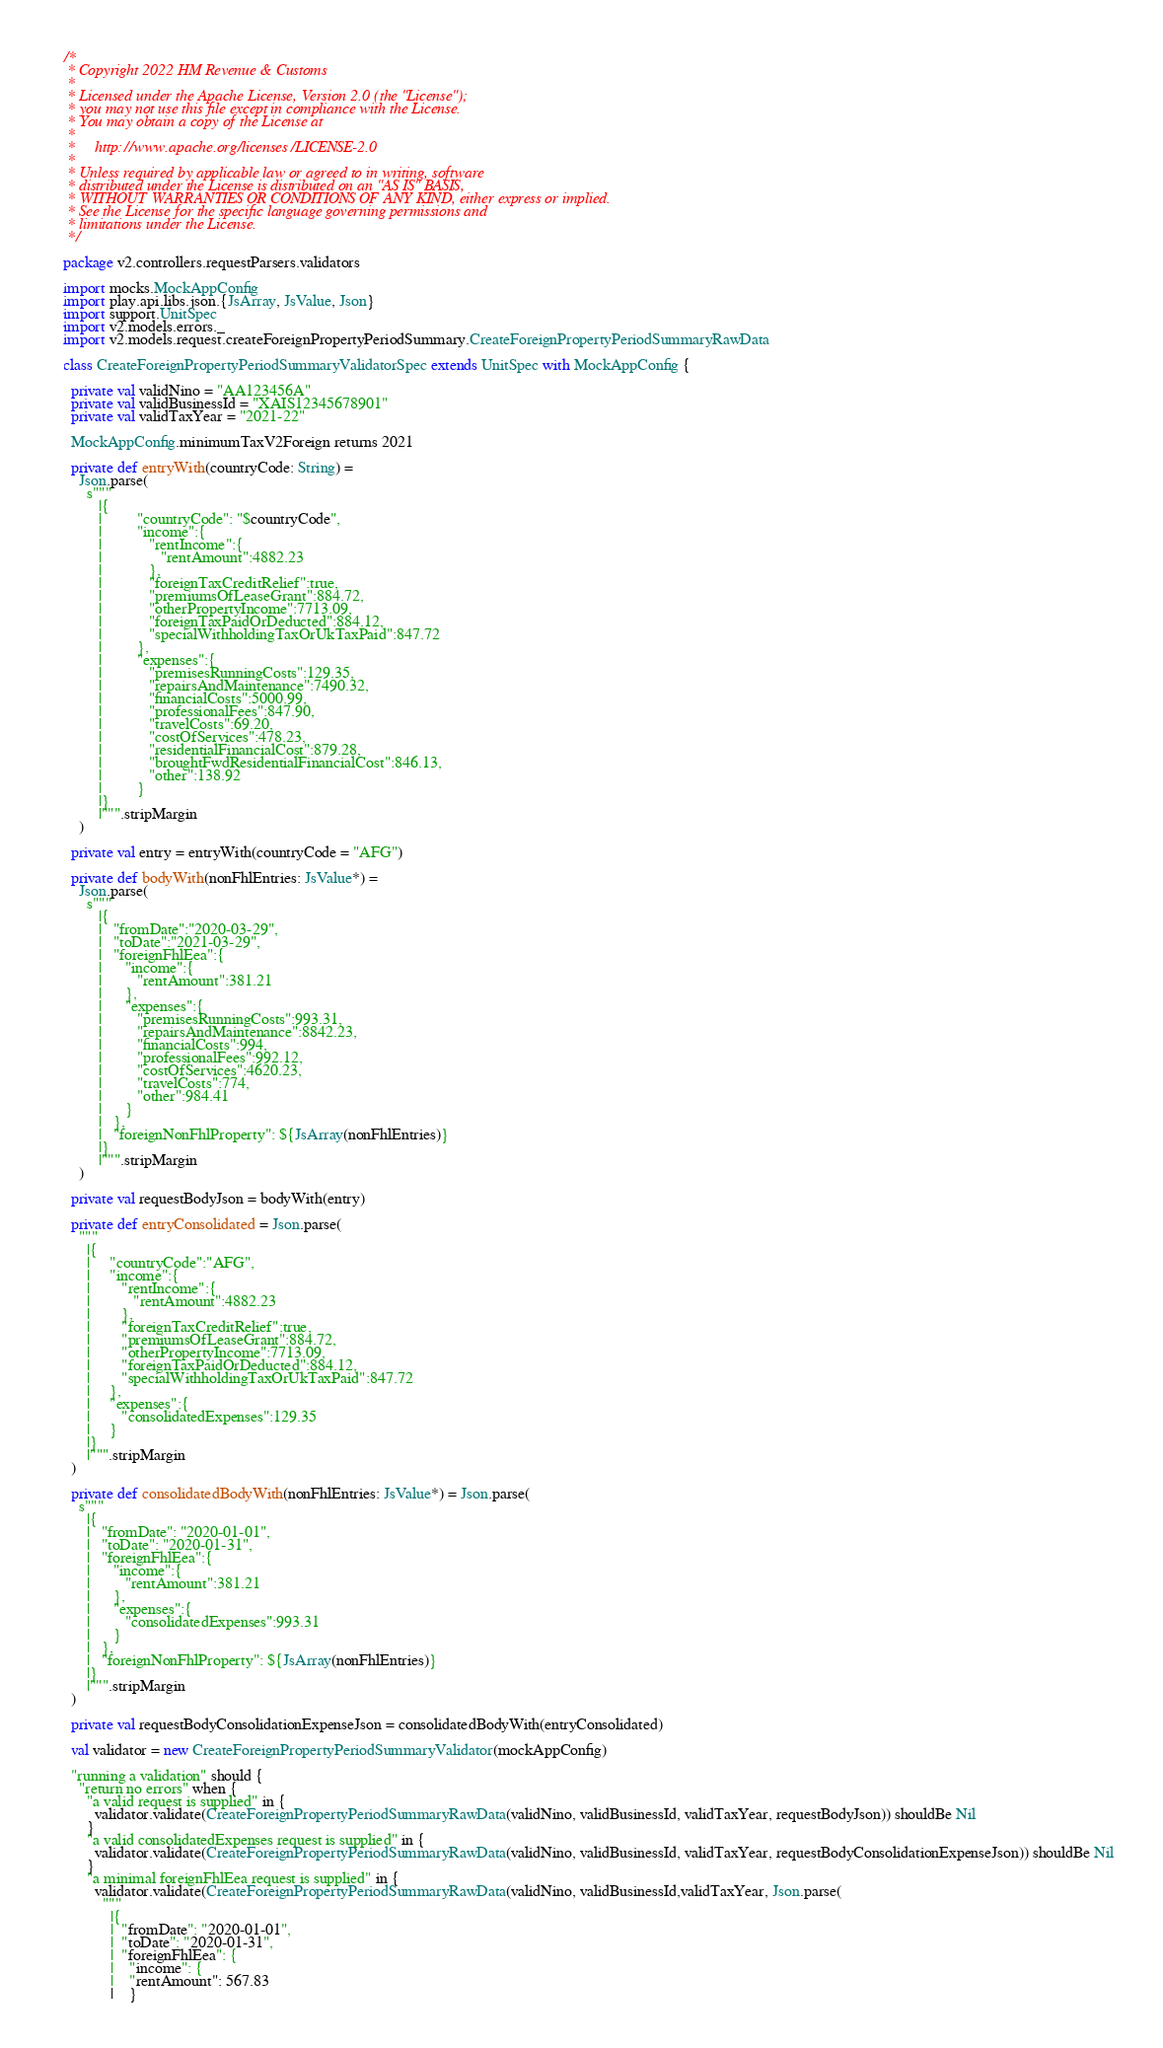<code> <loc_0><loc_0><loc_500><loc_500><_Scala_>/*
 * Copyright 2022 HM Revenue & Customs
 *
 * Licensed under the Apache License, Version 2.0 (the "License");
 * you may not use this file except in compliance with the License.
 * You may obtain a copy of the License at
 *
 *     http://www.apache.org/licenses/LICENSE-2.0
 *
 * Unless required by applicable law or agreed to in writing, software
 * distributed under the License is distributed on an "AS IS" BASIS,
 * WITHOUT WARRANTIES OR CONDITIONS OF ANY KIND, either express or implied.
 * See the License for the specific language governing permissions and
 * limitations under the License.
 */

package v2.controllers.requestParsers.validators

import mocks.MockAppConfig
import play.api.libs.json.{JsArray, JsValue, Json}
import support.UnitSpec
import v2.models.errors._
import v2.models.request.createForeignPropertyPeriodSummary.CreateForeignPropertyPeriodSummaryRawData

class CreateForeignPropertyPeriodSummaryValidatorSpec extends UnitSpec with MockAppConfig {

  private val validNino = "AA123456A"
  private val validBusinessId = "XAIS12345678901"
  private val validTaxYear = "2021-22"

  MockAppConfig.minimumTaxV2Foreign returns 2021

  private def entryWith(countryCode: String) =
    Json.parse(
      s"""
         |{
         |         "countryCode": "$countryCode",
         |         "income":{
         |            "rentIncome":{
         |               "rentAmount":4882.23
         |            },
         |            "foreignTaxCreditRelief":true,
         |            "premiumsOfLeaseGrant":884.72,
         |            "otherPropertyIncome":7713.09,
         |            "foreignTaxPaidOrDeducted":884.12,
         |            "specialWithholdingTaxOrUkTaxPaid":847.72
         |         },
         |         "expenses":{
         |            "premisesRunningCosts":129.35,
         |            "repairsAndMaintenance":7490.32,
         |            "financialCosts":5000.99,
         |            "professionalFees":847.90,
         |            "travelCosts":69.20,
         |            "costOfServices":478.23,
         |            "residentialFinancialCost":879.28,
         |            "broughtFwdResidentialFinancialCost":846.13,
         |            "other":138.92
         |         }
         |}
         |""".stripMargin
    )

  private val entry = entryWith(countryCode = "AFG")

  private def bodyWith(nonFhlEntries: JsValue*) =
    Json.parse(
      s"""
         |{
         |   "fromDate":"2020-03-29",
         |   "toDate":"2021-03-29",
         |   "foreignFhlEea":{
         |      "income":{
         |         "rentAmount":381.21
         |      },
         |      "expenses":{
         |         "premisesRunningCosts":993.31,
         |         "repairsAndMaintenance":8842.23,
         |         "financialCosts":994,
         |         "professionalFees":992.12,
         |         "costOfServices":4620.23,
         |         "travelCosts":774,
         |         "other":984.41
         |      }
         |   },
         |   "foreignNonFhlProperty": ${JsArray(nonFhlEntries)}
         |}
         |""".stripMargin
    )

  private val requestBodyJson = bodyWith(entry)

  private def entryConsolidated = Json.parse(
    """
      |{
      |     "countryCode":"AFG",
      |     "income":{
      |        "rentIncome":{
      |           "rentAmount":4882.23
      |        },
      |        "foreignTaxCreditRelief":true,
      |        "premiumsOfLeaseGrant":884.72,
      |        "otherPropertyIncome":7713.09,
      |        "foreignTaxPaidOrDeducted":884.12,
      |        "specialWithholdingTaxOrUkTaxPaid":847.72
      |     },
      |     "expenses":{
      |        "consolidatedExpenses":129.35
      |     }
      |}
      |""".stripMargin
  )

  private def consolidatedBodyWith(nonFhlEntries: JsValue*) = Json.parse(
    s"""
      |{
      |   "fromDate": "2020-01-01",
      |   "toDate": "2020-01-31",
      |   "foreignFhlEea":{
      |      "income":{
      |         "rentAmount":381.21
      |      },
      |      "expenses":{
      |         "consolidatedExpenses":993.31
      |      }
      |   },
      |   "foreignNonFhlProperty": ${JsArray(nonFhlEntries)}
      |}
      |""".stripMargin
  )

  private val requestBodyConsolidationExpenseJson = consolidatedBodyWith(entryConsolidated)

  val validator = new CreateForeignPropertyPeriodSummaryValidator(mockAppConfig)

  "running a validation" should {
    "return no errors" when {
      "a valid request is supplied" in {
        validator.validate(CreateForeignPropertyPeriodSummaryRawData(validNino, validBusinessId, validTaxYear, requestBodyJson)) shouldBe Nil
      }
      "a valid consolidatedExpenses request is supplied" in {
        validator.validate(CreateForeignPropertyPeriodSummaryRawData(validNino, validBusinessId, validTaxYear, requestBodyConsolidationExpenseJson)) shouldBe Nil
      }
      "a minimal foreignFhlEea request is supplied" in {
        validator.validate(CreateForeignPropertyPeriodSummaryRawData(validNino, validBusinessId,validTaxYear, Json.parse(
          """
            |{
            |  "fromDate": "2020-01-01",
            |  "toDate": "2020-01-31",
            |  "foreignFhlEea": {
            |    "income": {
            |    "rentAmount": 567.83
            |    }</code> 